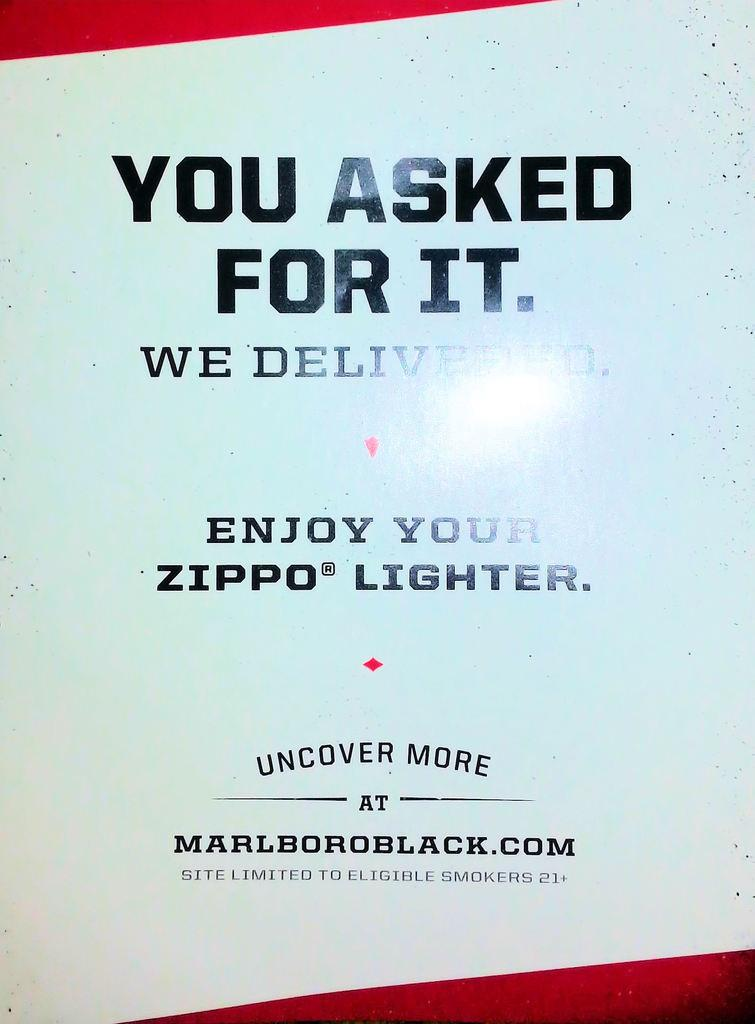<image>
Create a compact narrative representing the image presented. A sign that says "you asked for it" gives a url where people can get more information. 